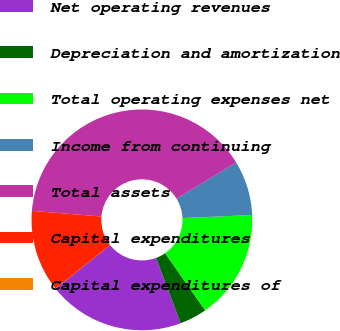Convert chart. <chart><loc_0><loc_0><loc_500><loc_500><pie_chart><fcel>Net operating revenues<fcel>Depreciation and amortization<fcel>Total operating expenses net<fcel>Income from continuing<fcel>Total assets<fcel>Capital expenditures<fcel>Capital expenditures of<nl><fcel>20.0%<fcel>4.01%<fcel>16.0%<fcel>8.0%<fcel>39.99%<fcel>12.0%<fcel>0.01%<nl></chart> 